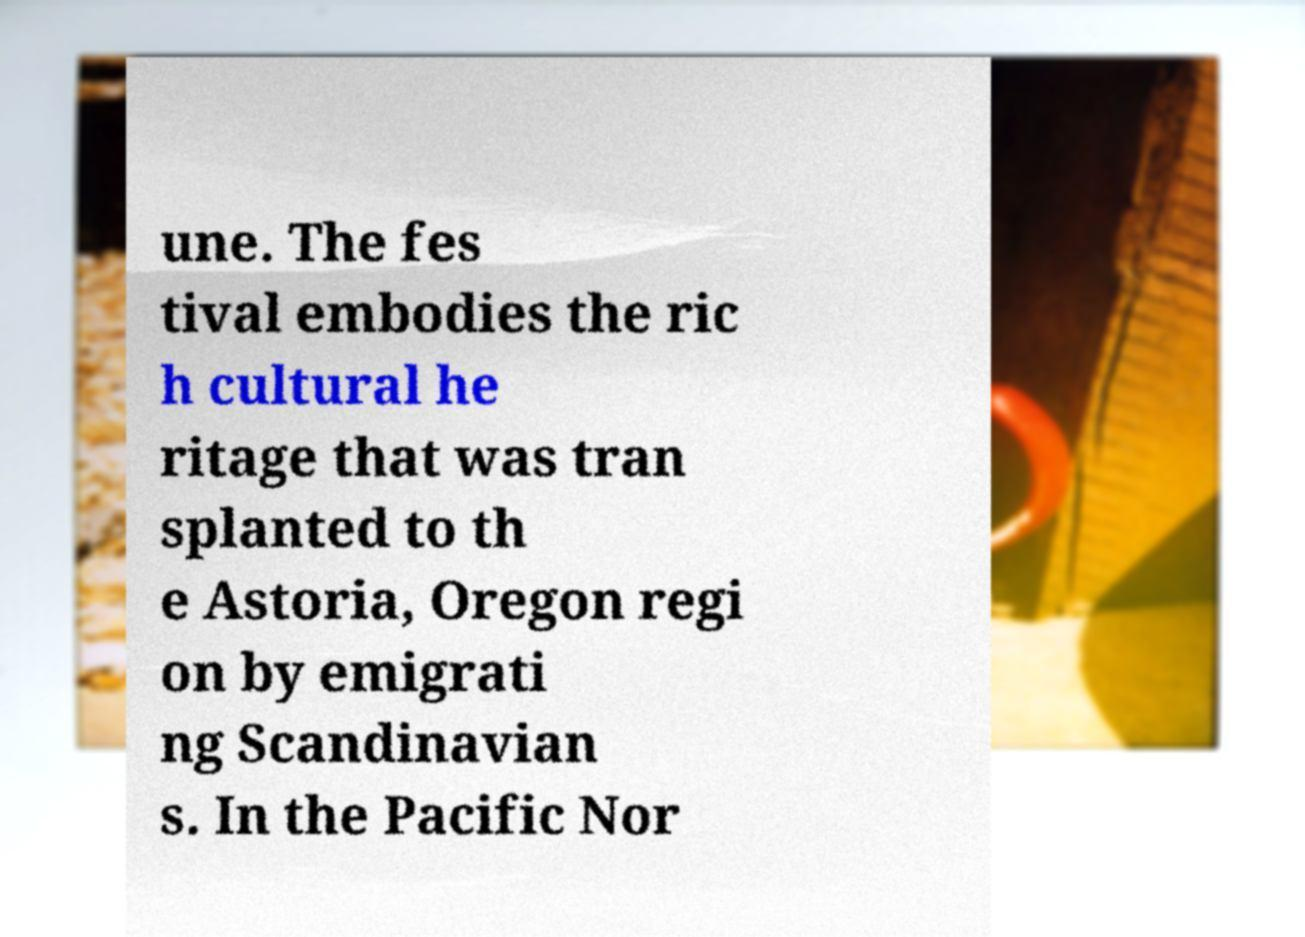For documentation purposes, I need the text within this image transcribed. Could you provide that? une. The fes tival embodies the ric h cultural he ritage that was tran splanted to th e Astoria, Oregon regi on by emigrati ng Scandinavian s. In the Pacific Nor 